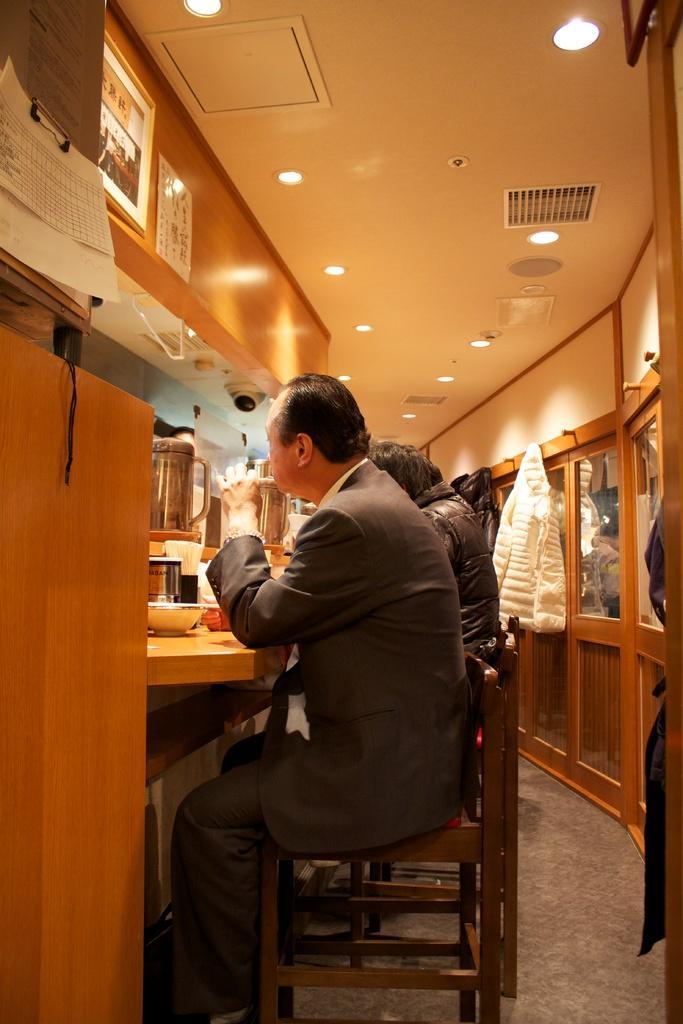Please provide a concise description of this image. In this image I can see persons sitting on the chairs. This is a table. There are some objects placed on the table. This is a bowl, and I think this is a kind of a jug. And here is a kind of camera which is attached to the rooftop. I can see a pages attached to the wall and this is a rooftop. Here is the ceiling light. I can see a jacket which is hanged to the wall. I can see a photo frame which is attached to the wood. 